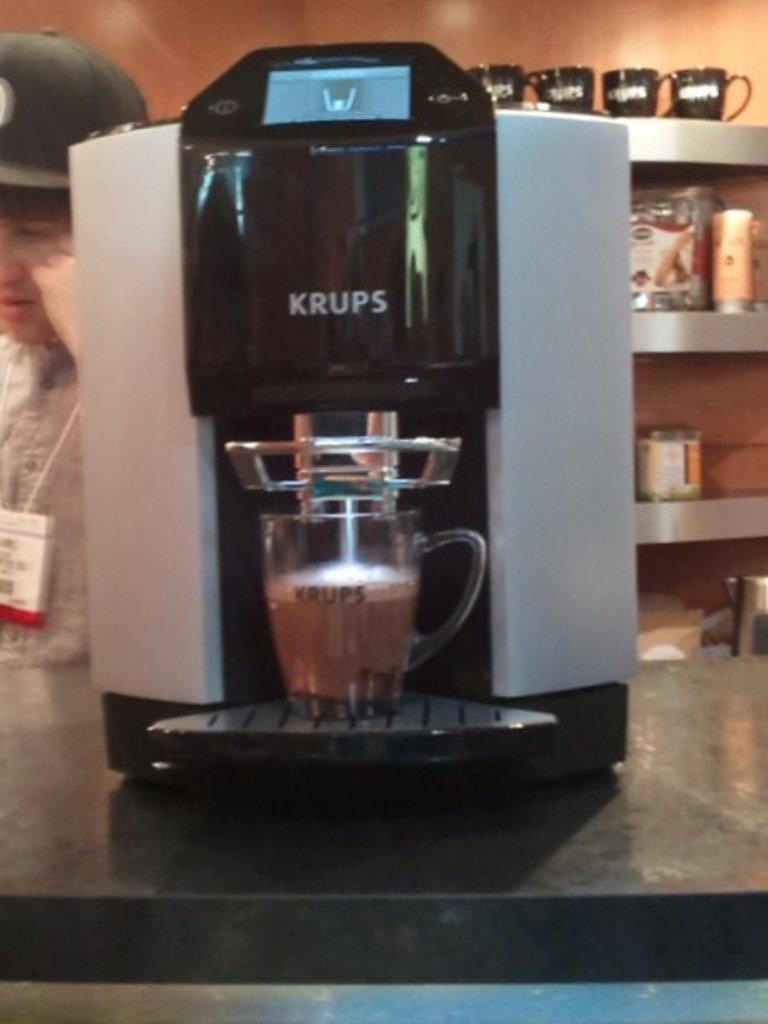In one or two sentences, can you explain what this image depicts? In this picture we can see a coffee maker. There is a cup. We can see a white object on the left side. There are few cups and other objects on the shelves. 